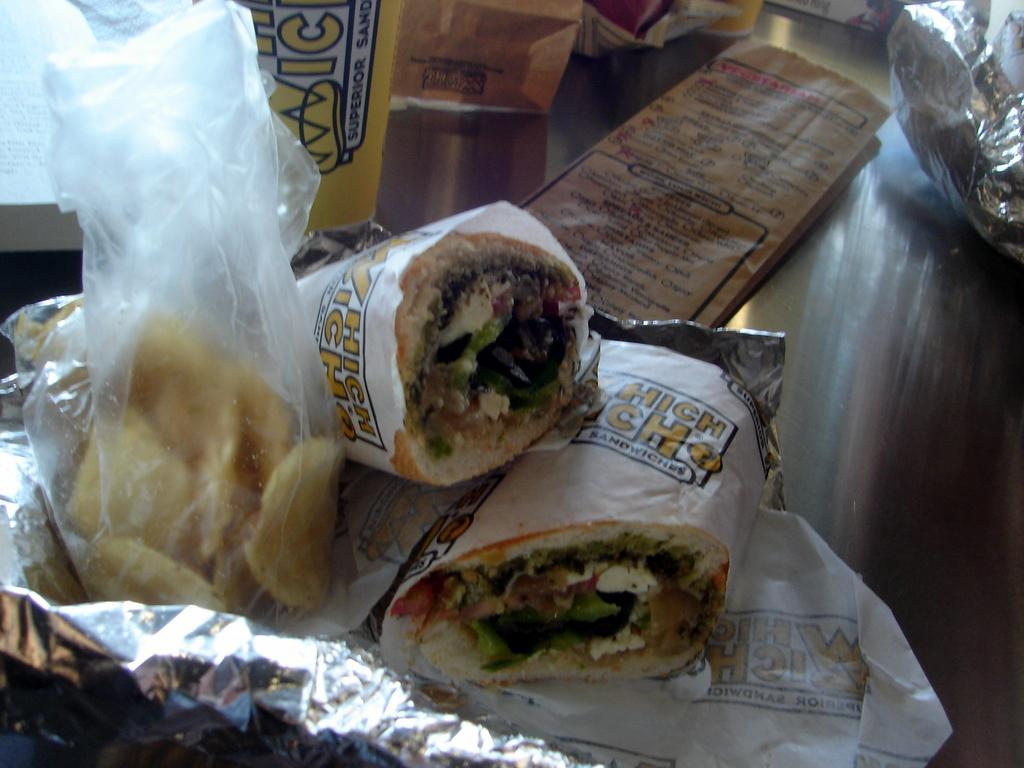How would you summarize this image in a sentence or two? In the image there are sandwiches and potato chips in covers on a table along with some food products in the back. 